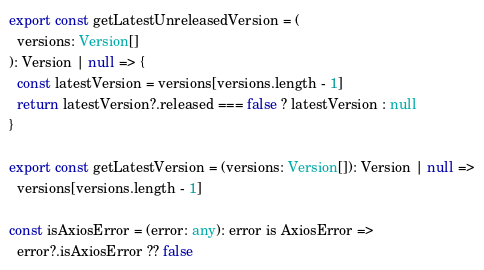<code> <loc_0><loc_0><loc_500><loc_500><_TypeScript_>export const getLatestUnreleasedVersion = (
  versions: Version[]
): Version | null => {
  const latestVersion = versions[versions.length - 1]
  return latestVersion?.released === false ? latestVersion : null
}

export const getLatestVersion = (versions: Version[]): Version | null =>
  versions[versions.length - 1]

const isAxiosError = (error: any): error is AxiosError =>
  error?.isAxiosError ?? false
</code> 